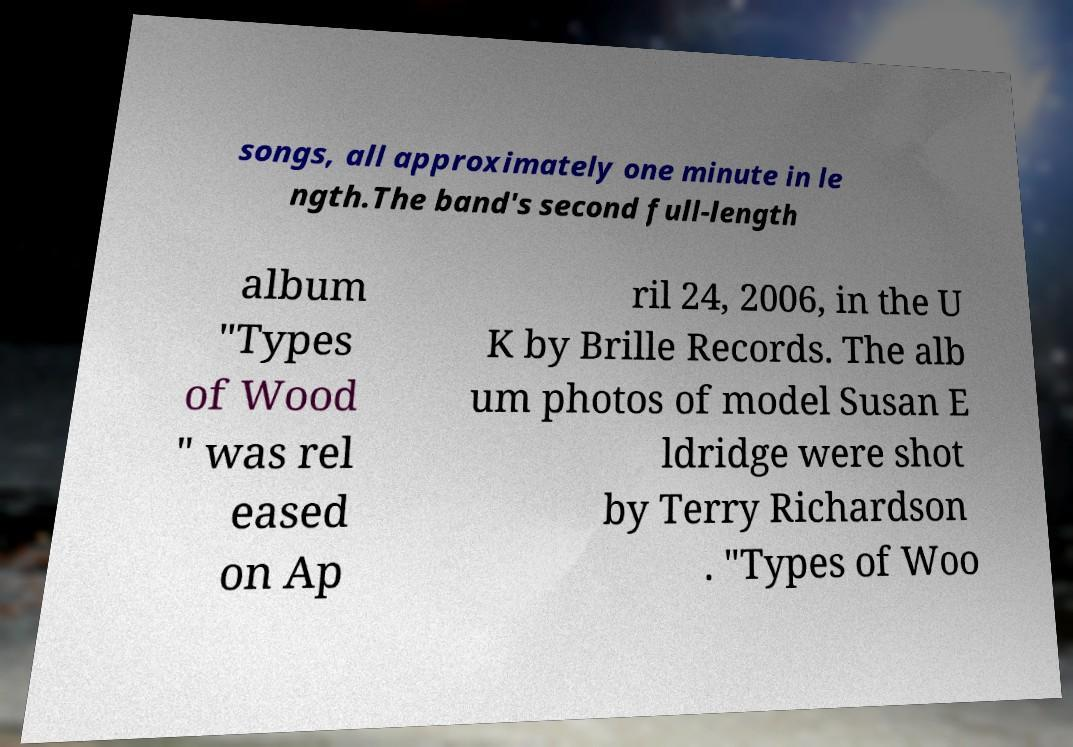Please identify and transcribe the text found in this image. songs, all approximately one minute in le ngth.The band's second full-length album "Types of Wood " was rel eased on Ap ril 24, 2006, in the U K by Brille Records. The alb um photos of model Susan E ldridge were shot by Terry Richardson . "Types of Woo 